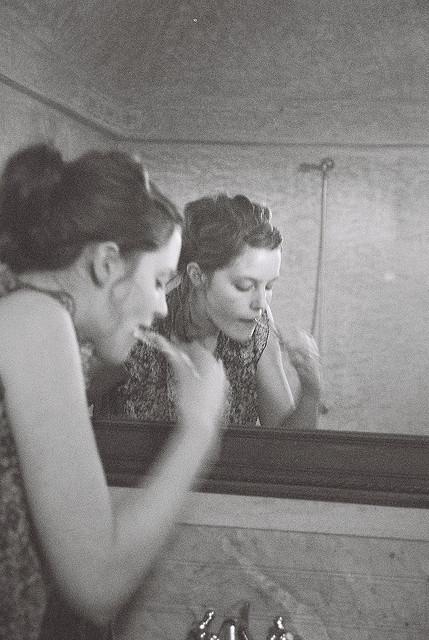Is this woman using an iPhone?
Short answer required. No. What is in her mouth?
Quick response, please. Toothbrush. Is there anyone in the photo?
Quick response, please. Yes. Which hand is the toothbrush in?
Give a very brief answer. Right. Why is this woman bending over the sink?
Quick response, please. Brushing teeth. 